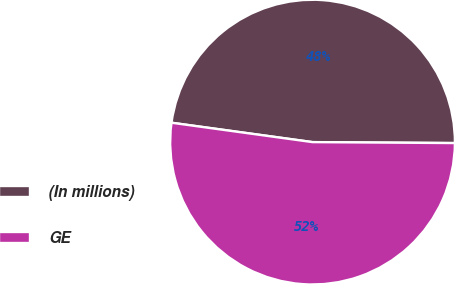Convert chart. <chart><loc_0><loc_0><loc_500><loc_500><pie_chart><fcel>(In millions)<fcel>GE<nl><fcel>47.93%<fcel>52.07%<nl></chart> 